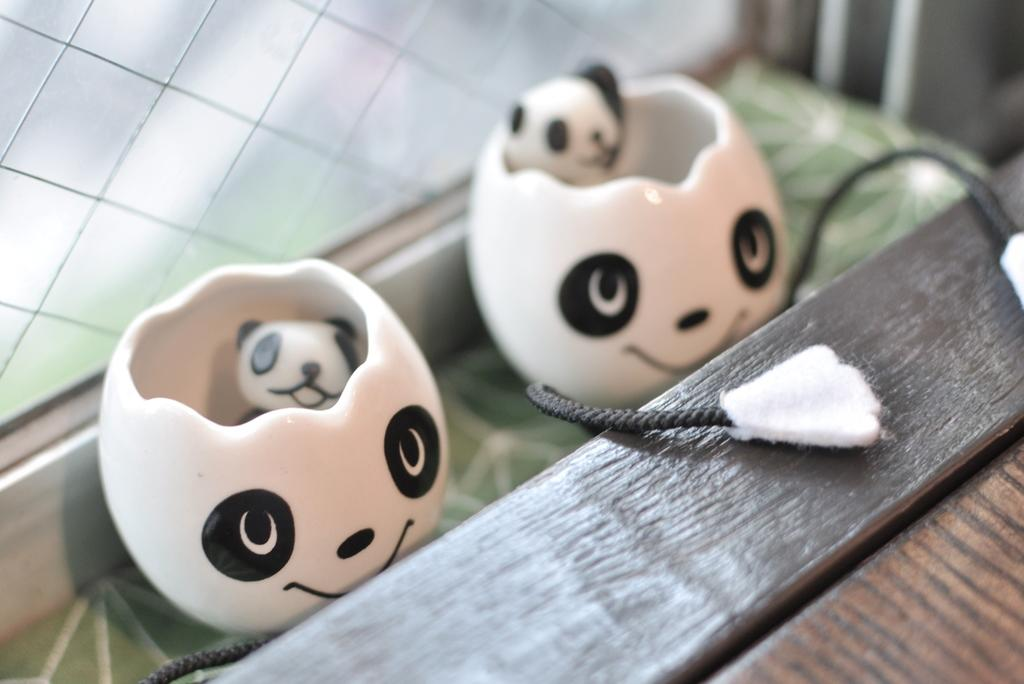What type of toys are present in the image? There are two toys with threads in the image. Is there anything else related to the toys in the image? Yes, there is an object associated with the toys. What can be seen in the background of the image? There is a window visible in the background of the image. Where is the park located in the image? There is no park present in the image. What type of hat is the toy wearing in the image? The toys in the image do not have hats, and there is no hat present. 